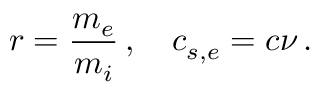<formula> <loc_0><loc_0><loc_500><loc_500>r = \frac { m _ { e } } { m _ { i } } \, , \quad c _ { s , e } = c \nu \, .</formula> 